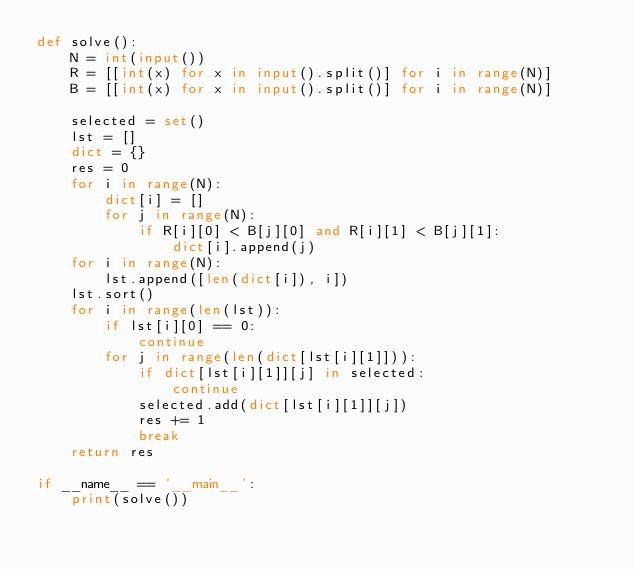<code> <loc_0><loc_0><loc_500><loc_500><_Python_>def solve():
    N = int(input())
    R = [[int(x) for x in input().split()] for i in range(N)]
    B = [[int(x) for x in input().split()] for i in range(N)]

    selected = set()
    lst = []
    dict = {}
    res = 0
    for i in range(N):
        dict[i] = []
        for j in range(N):
            if R[i][0] < B[j][0] and R[i][1] < B[j][1]:
                dict[i].append(j)
    for i in range(N):
        lst.append([len(dict[i]), i])
    lst.sort()
    for i in range(len(lst)):
        if lst[i][0] == 0:
            continue
        for j in range(len(dict[lst[i][1]])):
            if dict[lst[i][1]][j] in selected:
                continue
            selected.add(dict[lst[i][1]][j])
            res += 1
            break
    return res

if __name__ == '__main__':
    print(solve())
</code> 